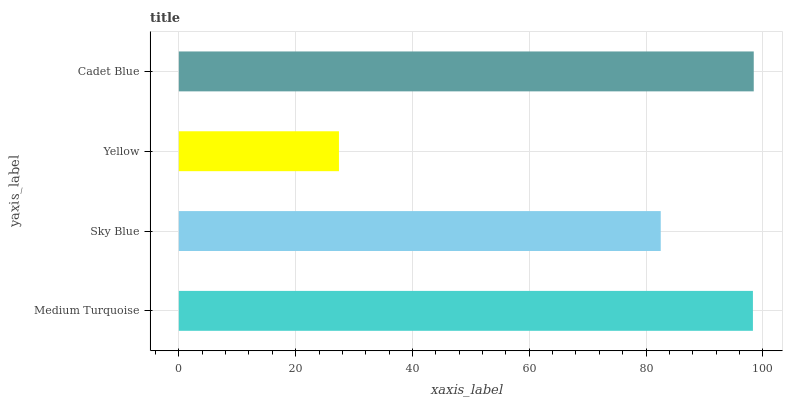Is Yellow the minimum?
Answer yes or no. Yes. Is Cadet Blue the maximum?
Answer yes or no. Yes. Is Sky Blue the minimum?
Answer yes or no. No. Is Sky Blue the maximum?
Answer yes or no. No. Is Medium Turquoise greater than Sky Blue?
Answer yes or no. Yes. Is Sky Blue less than Medium Turquoise?
Answer yes or no. Yes. Is Sky Blue greater than Medium Turquoise?
Answer yes or no. No. Is Medium Turquoise less than Sky Blue?
Answer yes or no. No. Is Medium Turquoise the high median?
Answer yes or no. Yes. Is Sky Blue the low median?
Answer yes or no. Yes. Is Yellow the high median?
Answer yes or no. No. Is Medium Turquoise the low median?
Answer yes or no. No. 